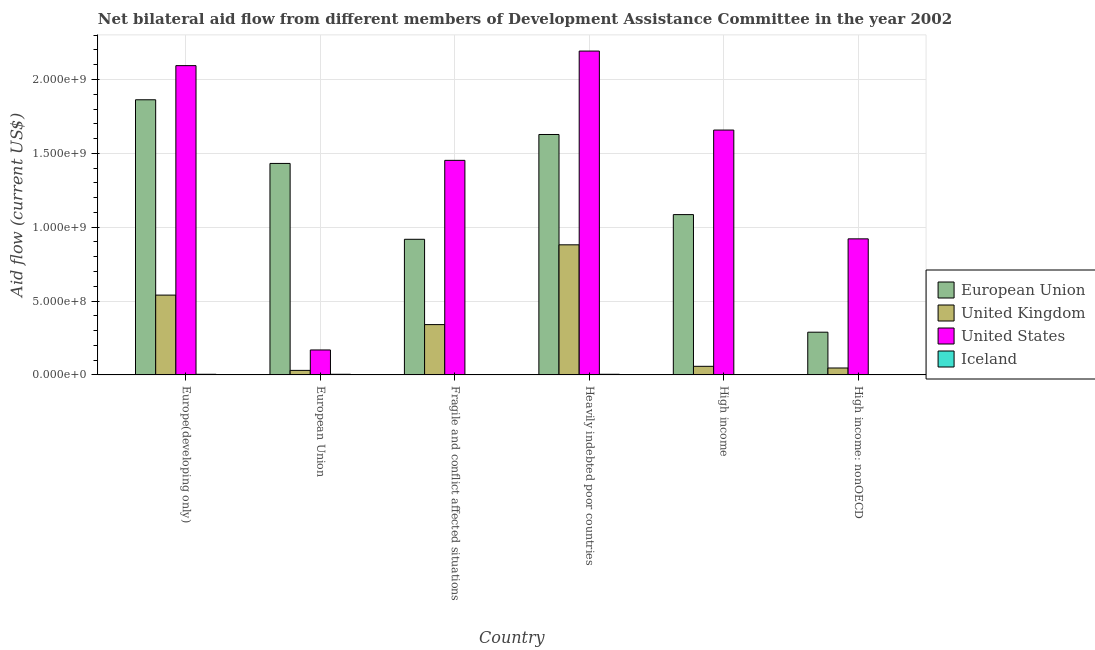How many groups of bars are there?
Provide a short and direct response. 6. Are the number of bars per tick equal to the number of legend labels?
Keep it short and to the point. Yes. What is the label of the 3rd group of bars from the left?
Your answer should be compact. Fragile and conflict affected situations. In how many cases, is the number of bars for a given country not equal to the number of legend labels?
Ensure brevity in your answer.  0. What is the amount of aid given by uk in High income?
Give a very brief answer. 5.81e+07. Across all countries, what is the maximum amount of aid given by eu?
Make the answer very short. 1.86e+09. Across all countries, what is the minimum amount of aid given by uk?
Provide a short and direct response. 3.07e+07. In which country was the amount of aid given by uk maximum?
Ensure brevity in your answer.  Heavily indebted poor countries. In which country was the amount of aid given by uk minimum?
Provide a short and direct response. European Union. What is the total amount of aid given by uk in the graph?
Provide a short and direct response. 1.90e+09. What is the difference between the amount of aid given by us in Heavily indebted poor countries and that in High income?
Your response must be concise. 5.35e+08. What is the difference between the amount of aid given by us in High income: nonOECD and the amount of aid given by uk in High income?
Your answer should be compact. 8.63e+08. What is the average amount of aid given by uk per country?
Provide a succinct answer. 3.16e+08. What is the difference between the amount of aid given by us and amount of aid given by eu in High income?
Give a very brief answer. 5.72e+08. In how many countries, is the amount of aid given by iceland greater than 1300000000 US$?
Your response must be concise. 0. What is the ratio of the amount of aid given by eu in Fragile and conflict affected situations to that in High income?
Give a very brief answer. 0.85. Is the amount of aid given by uk in Fragile and conflict affected situations less than that in High income?
Give a very brief answer. No. What is the difference between the highest and the second highest amount of aid given by eu?
Your answer should be compact. 2.35e+08. What is the difference between the highest and the lowest amount of aid given by us?
Make the answer very short. 2.02e+09. Is the sum of the amount of aid given by us in European Union and High income: nonOECD greater than the maximum amount of aid given by uk across all countries?
Your response must be concise. Yes. Is it the case that in every country, the sum of the amount of aid given by iceland and amount of aid given by uk is greater than the sum of amount of aid given by eu and amount of aid given by us?
Offer a terse response. No. What does the 2nd bar from the right in High income represents?
Keep it short and to the point. United States. Are all the bars in the graph horizontal?
Provide a short and direct response. No. How many countries are there in the graph?
Offer a very short reply. 6. What is the difference between two consecutive major ticks on the Y-axis?
Make the answer very short. 5.00e+08. Does the graph contain any zero values?
Keep it short and to the point. No. Does the graph contain grids?
Provide a short and direct response. Yes. Where does the legend appear in the graph?
Offer a terse response. Center right. How are the legend labels stacked?
Offer a very short reply. Vertical. What is the title of the graph?
Offer a very short reply. Net bilateral aid flow from different members of Development Assistance Committee in the year 2002. Does "UNDP" appear as one of the legend labels in the graph?
Give a very brief answer. No. What is the label or title of the Y-axis?
Keep it short and to the point. Aid flow (current US$). What is the Aid flow (current US$) of European Union in Europe(developing only)?
Your response must be concise. 1.86e+09. What is the Aid flow (current US$) in United Kingdom in Europe(developing only)?
Your answer should be very brief. 5.40e+08. What is the Aid flow (current US$) of United States in Europe(developing only)?
Your answer should be compact. 2.09e+09. What is the Aid flow (current US$) of Iceland in Europe(developing only)?
Provide a short and direct response. 4.30e+06. What is the Aid flow (current US$) of European Union in European Union?
Your answer should be very brief. 1.43e+09. What is the Aid flow (current US$) of United Kingdom in European Union?
Provide a succinct answer. 3.07e+07. What is the Aid flow (current US$) of United States in European Union?
Your answer should be very brief. 1.69e+08. What is the Aid flow (current US$) of Iceland in European Union?
Offer a very short reply. 4.30e+06. What is the Aid flow (current US$) of European Union in Fragile and conflict affected situations?
Give a very brief answer. 9.18e+08. What is the Aid flow (current US$) in United Kingdom in Fragile and conflict affected situations?
Your response must be concise. 3.41e+08. What is the Aid flow (current US$) of United States in Fragile and conflict affected situations?
Your response must be concise. 1.45e+09. What is the Aid flow (current US$) of Iceland in Fragile and conflict affected situations?
Your response must be concise. 1.18e+06. What is the Aid flow (current US$) of European Union in Heavily indebted poor countries?
Keep it short and to the point. 1.63e+09. What is the Aid flow (current US$) of United Kingdom in Heavily indebted poor countries?
Offer a very short reply. 8.81e+08. What is the Aid flow (current US$) in United States in Heavily indebted poor countries?
Ensure brevity in your answer.  2.19e+09. What is the Aid flow (current US$) of Iceland in Heavily indebted poor countries?
Ensure brevity in your answer.  4.30e+06. What is the Aid flow (current US$) in European Union in High income?
Provide a succinct answer. 1.09e+09. What is the Aid flow (current US$) in United Kingdom in High income?
Keep it short and to the point. 5.81e+07. What is the Aid flow (current US$) in United States in High income?
Offer a terse response. 1.66e+09. What is the Aid flow (current US$) in Iceland in High income?
Make the answer very short. 1.57e+06. What is the Aid flow (current US$) in European Union in High income: nonOECD?
Make the answer very short. 2.89e+08. What is the Aid flow (current US$) in United Kingdom in High income: nonOECD?
Offer a terse response. 4.68e+07. What is the Aid flow (current US$) in United States in High income: nonOECD?
Your response must be concise. 9.21e+08. What is the Aid flow (current US$) in Iceland in High income: nonOECD?
Provide a succinct answer. 1.07e+06. Across all countries, what is the maximum Aid flow (current US$) in European Union?
Provide a short and direct response. 1.86e+09. Across all countries, what is the maximum Aid flow (current US$) in United Kingdom?
Offer a terse response. 8.81e+08. Across all countries, what is the maximum Aid flow (current US$) in United States?
Give a very brief answer. 2.19e+09. Across all countries, what is the maximum Aid flow (current US$) in Iceland?
Offer a terse response. 4.30e+06. Across all countries, what is the minimum Aid flow (current US$) of European Union?
Ensure brevity in your answer.  2.89e+08. Across all countries, what is the minimum Aid flow (current US$) of United Kingdom?
Your response must be concise. 3.07e+07. Across all countries, what is the minimum Aid flow (current US$) in United States?
Your response must be concise. 1.69e+08. Across all countries, what is the minimum Aid flow (current US$) of Iceland?
Keep it short and to the point. 1.07e+06. What is the total Aid flow (current US$) of European Union in the graph?
Your answer should be very brief. 7.22e+09. What is the total Aid flow (current US$) of United Kingdom in the graph?
Make the answer very short. 1.90e+09. What is the total Aid flow (current US$) in United States in the graph?
Provide a short and direct response. 8.49e+09. What is the total Aid flow (current US$) of Iceland in the graph?
Your answer should be very brief. 1.67e+07. What is the difference between the Aid flow (current US$) of European Union in Europe(developing only) and that in European Union?
Your answer should be very brief. 4.31e+08. What is the difference between the Aid flow (current US$) of United Kingdom in Europe(developing only) and that in European Union?
Your answer should be very brief. 5.10e+08. What is the difference between the Aid flow (current US$) in United States in Europe(developing only) and that in European Union?
Offer a terse response. 1.93e+09. What is the difference between the Aid flow (current US$) in Iceland in Europe(developing only) and that in European Union?
Your answer should be compact. 0. What is the difference between the Aid flow (current US$) of European Union in Europe(developing only) and that in Fragile and conflict affected situations?
Make the answer very short. 9.45e+08. What is the difference between the Aid flow (current US$) of United Kingdom in Europe(developing only) and that in Fragile and conflict affected situations?
Provide a succinct answer. 2.00e+08. What is the difference between the Aid flow (current US$) of United States in Europe(developing only) and that in Fragile and conflict affected situations?
Offer a terse response. 6.41e+08. What is the difference between the Aid flow (current US$) in Iceland in Europe(developing only) and that in Fragile and conflict affected situations?
Give a very brief answer. 3.12e+06. What is the difference between the Aid flow (current US$) of European Union in Europe(developing only) and that in Heavily indebted poor countries?
Keep it short and to the point. 2.35e+08. What is the difference between the Aid flow (current US$) in United Kingdom in Europe(developing only) and that in Heavily indebted poor countries?
Ensure brevity in your answer.  -3.41e+08. What is the difference between the Aid flow (current US$) in United States in Europe(developing only) and that in Heavily indebted poor countries?
Offer a terse response. -9.86e+07. What is the difference between the Aid flow (current US$) in Iceland in Europe(developing only) and that in Heavily indebted poor countries?
Ensure brevity in your answer.  0. What is the difference between the Aid flow (current US$) in European Union in Europe(developing only) and that in High income?
Give a very brief answer. 7.77e+08. What is the difference between the Aid flow (current US$) of United Kingdom in Europe(developing only) and that in High income?
Offer a very short reply. 4.82e+08. What is the difference between the Aid flow (current US$) in United States in Europe(developing only) and that in High income?
Keep it short and to the point. 4.36e+08. What is the difference between the Aid flow (current US$) in Iceland in Europe(developing only) and that in High income?
Your response must be concise. 2.73e+06. What is the difference between the Aid flow (current US$) in European Union in Europe(developing only) and that in High income: nonOECD?
Your response must be concise. 1.57e+09. What is the difference between the Aid flow (current US$) in United Kingdom in Europe(developing only) and that in High income: nonOECD?
Provide a succinct answer. 4.93e+08. What is the difference between the Aid flow (current US$) in United States in Europe(developing only) and that in High income: nonOECD?
Your answer should be compact. 1.17e+09. What is the difference between the Aid flow (current US$) of Iceland in Europe(developing only) and that in High income: nonOECD?
Ensure brevity in your answer.  3.23e+06. What is the difference between the Aid flow (current US$) of European Union in European Union and that in Fragile and conflict affected situations?
Your answer should be very brief. 5.14e+08. What is the difference between the Aid flow (current US$) of United Kingdom in European Union and that in Fragile and conflict affected situations?
Your answer should be very brief. -3.10e+08. What is the difference between the Aid flow (current US$) in United States in European Union and that in Fragile and conflict affected situations?
Your answer should be compact. -1.28e+09. What is the difference between the Aid flow (current US$) in Iceland in European Union and that in Fragile and conflict affected situations?
Keep it short and to the point. 3.12e+06. What is the difference between the Aid flow (current US$) in European Union in European Union and that in Heavily indebted poor countries?
Your answer should be very brief. -1.96e+08. What is the difference between the Aid flow (current US$) of United Kingdom in European Union and that in Heavily indebted poor countries?
Make the answer very short. -8.50e+08. What is the difference between the Aid flow (current US$) in United States in European Union and that in Heavily indebted poor countries?
Give a very brief answer. -2.02e+09. What is the difference between the Aid flow (current US$) in Iceland in European Union and that in Heavily indebted poor countries?
Provide a short and direct response. 0. What is the difference between the Aid flow (current US$) of European Union in European Union and that in High income?
Your answer should be very brief. 3.46e+08. What is the difference between the Aid flow (current US$) in United Kingdom in European Union and that in High income?
Your answer should be compact. -2.74e+07. What is the difference between the Aid flow (current US$) in United States in European Union and that in High income?
Provide a short and direct response. -1.49e+09. What is the difference between the Aid flow (current US$) in Iceland in European Union and that in High income?
Make the answer very short. 2.73e+06. What is the difference between the Aid flow (current US$) in European Union in European Union and that in High income: nonOECD?
Provide a short and direct response. 1.14e+09. What is the difference between the Aid flow (current US$) of United Kingdom in European Union and that in High income: nonOECD?
Make the answer very short. -1.61e+07. What is the difference between the Aid flow (current US$) in United States in European Union and that in High income: nonOECD?
Keep it short and to the point. -7.52e+08. What is the difference between the Aid flow (current US$) in Iceland in European Union and that in High income: nonOECD?
Your response must be concise. 3.23e+06. What is the difference between the Aid flow (current US$) in European Union in Fragile and conflict affected situations and that in Heavily indebted poor countries?
Your answer should be compact. -7.09e+08. What is the difference between the Aid flow (current US$) of United Kingdom in Fragile and conflict affected situations and that in Heavily indebted poor countries?
Keep it short and to the point. -5.40e+08. What is the difference between the Aid flow (current US$) of United States in Fragile and conflict affected situations and that in Heavily indebted poor countries?
Provide a short and direct response. -7.40e+08. What is the difference between the Aid flow (current US$) in Iceland in Fragile and conflict affected situations and that in Heavily indebted poor countries?
Provide a succinct answer. -3.12e+06. What is the difference between the Aid flow (current US$) in European Union in Fragile and conflict affected situations and that in High income?
Provide a succinct answer. -1.67e+08. What is the difference between the Aid flow (current US$) of United Kingdom in Fragile and conflict affected situations and that in High income?
Provide a short and direct response. 2.82e+08. What is the difference between the Aid flow (current US$) of United States in Fragile and conflict affected situations and that in High income?
Your response must be concise. -2.05e+08. What is the difference between the Aid flow (current US$) in Iceland in Fragile and conflict affected situations and that in High income?
Make the answer very short. -3.90e+05. What is the difference between the Aid flow (current US$) of European Union in Fragile and conflict affected situations and that in High income: nonOECD?
Make the answer very short. 6.29e+08. What is the difference between the Aid flow (current US$) of United Kingdom in Fragile and conflict affected situations and that in High income: nonOECD?
Your answer should be very brief. 2.94e+08. What is the difference between the Aid flow (current US$) in United States in Fragile and conflict affected situations and that in High income: nonOECD?
Offer a very short reply. 5.31e+08. What is the difference between the Aid flow (current US$) in European Union in Heavily indebted poor countries and that in High income?
Offer a terse response. 5.42e+08. What is the difference between the Aid flow (current US$) of United Kingdom in Heavily indebted poor countries and that in High income?
Make the answer very short. 8.23e+08. What is the difference between the Aid flow (current US$) of United States in Heavily indebted poor countries and that in High income?
Provide a short and direct response. 5.35e+08. What is the difference between the Aid flow (current US$) of Iceland in Heavily indebted poor countries and that in High income?
Provide a succinct answer. 2.73e+06. What is the difference between the Aid flow (current US$) in European Union in Heavily indebted poor countries and that in High income: nonOECD?
Your answer should be very brief. 1.34e+09. What is the difference between the Aid flow (current US$) in United Kingdom in Heavily indebted poor countries and that in High income: nonOECD?
Give a very brief answer. 8.34e+08. What is the difference between the Aid flow (current US$) of United States in Heavily indebted poor countries and that in High income: nonOECD?
Your response must be concise. 1.27e+09. What is the difference between the Aid flow (current US$) in Iceland in Heavily indebted poor countries and that in High income: nonOECD?
Offer a very short reply. 3.23e+06. What is the difference between the Aid flow (current US$) in European Union in High income and that in High income: nonOECD?
Keep it short and to the point. 7.96e+08. What is the difference between the Aid flow (current US$) in United Kingdom in High income and that in High income: nonOECD?
Your response must be concise. 1.13e+07. What is the difference between the Aid flow (current US$) of United States in High income and that in High income: nonOECD?
Give a very brief answer. 7.37e+08. What is the difference between the Aid flow (current US$) in Iceland in High income and that in High income: nonOECD?
Give a very brief answer. 5.00e+05. What is the difference between the Aid flow (current US$) of European Union in Europe(developing only) and the Aid flow (current US$) of United Kingdom in European Union?
Make the answer very short. 1.83e+09. What is the difference between the Aid flow (current US$) of European Union in Europe(developing only) and the Aid flow (current US$) of United States in European Union?
Ensure brevity in your answer.  1.69e+09. What is the difference between the Aid flow (current US$) in European Union in Europe(developing only) and the Aid flow (current US$) in Iceland in European Union?
Provide a succinct answer. 1.86e+09. What is the difference between the Aid flow (current US$) of United Kingdom in Europe(developing only) and the Aid flow (current US$) of United States in European Union?
Your response must be concise. 3.71e+08. What is the difference between the Aid flow (current US$) in United Kingdom in Europe(developing only) and the Aid flow (current US$) in Iceland in European Union?
Provide a short and direct response. 5.36e+08. What is the difference between the Aid flow (current US$) in United States in Europe(developing only) and the Aid flow (current US$) in Iceland in European Union?
Your answer should be compact. 2.09e+09. What is the difference between the Aid flow (current US$) of European Union in Europe(developing only) and the Aid flow (current US$) of United Kingdom in Fragile and conflict affected situations?
Provide a succinct answer. 1.52e+09. What is the difference between the Aid flow (current US$) in European Union in Europe(developing only) and the Aid flow (current US$) in United States in Fragile and conflict affected situations?
Keep it short and to the point. 4.10e+08. What is the difference between the Aid flow (current US$) of European Union in Europe(developing only) and the Aid flow (current US$) of Iceland in Fragile and conflict affected situations?
Provide a succinct answer. 1.86e+09. What is the difference between the Aid flow (current US$) in United Kingdom in Europe(developing only) and the Aid flow (current US$) in United States in Fragile and conflict affected situations?
Make the answer very short. -9.12e+08. What is the difference between the Aid flow (current US$) in United Kingdom in Europe(developing only) and the Aid flow (current US$) in Iceland in Fragile and conflict affected situations?
Provide a short and direct response. 5.39e+08. What is the difference between the Aid flow (current US$) of United States in Europe(developing only) and the Aid flow (current US$) of Iceland in Fragile and conflict affected situations?
Your response must be concise. 2.09e+09. What is the difference between the Aid flow (current US$) in European Union in Europe(developing only) and the Aid flow (current US$) in United Kingdom in Heavily indebted poor countries?
Keep it short and to the point. 9.82e+08. What is the difference between the Aid flow (current US$) of European Union in Europe(developing only) and the Aid flow (current US$) of United States in Heavily indebted poor countries?
Your answer should be compact. -3.30e+08. What is the difference between the Aid flow (current US$) of European Union in Europe(developing only) and the Aid flow (current US$) of Iceland in Heavily indebted poor countries?
Keep it short and to the point. 1.86e+09. What is the difference between the Aid flow (current US$) of United Kingdom in Europe(developing only) and the Aid flow (current US$) of United States in Heavily indebted poor countries?
Ensure brevity in your answer.  -1.65e+09. What is the difference between the Aid flow (current US$) of United Kingdom in Europe(developing only) and the Aid flow (current US$) of Iceland in Heavily indebted poor countries?
Make the answer very short. 5.36e+08. What is the difference between the Aid flow (current US$) in United States in Europe(developing only) and the Aid flow (current US$) in Iceland in Heavily indebted poor countries?
Make the answer very short. 2.09e+09. What is the difference between the Aid flow (current US$) in European Union in Europe(developing only) and the Aid flow (current US$) in United Kingdom in High income?
Make the answer very short. 1.80e+09. What is the difference between the Aid flow (current US$) of European Union in Europe(developing only) and the Aid flow (current US$) of United States in High income?
Make the answer very short. 2.05e+08. What is the difference between the Aid flow (current US$) of European Union in Europe(developing only) and the Aid flow (current US$) of Iceland in High income?
Your response must be concise. 1.86e+09. What is the difference between the Aid flow (current US$) of United Kingdom in Europe(developing only) and the Aid flow (current US$) of United States in High income?
Your response must be concise. -1.12e+09. What is the difference between the Aid flow (current US$) in United Kingdom in Europe(developing only) and the Aid flow (current US$) in Iceland in High income?
Provide a short and direct response. 5.39e+08. What is the difference between the Aid flow (current US$) in United States in Europe(developing only) and the Aid flow (current US$) in Iceland in High income?
Your answer should be compact. 2.09e+09. What is the difference between the Aid flow (current US$) of European Union in Europe(developing only) and the Aid flow (current US$) of United Kingdom in High income: nonOECD?
Your response must be concise. 1.82e+09. What is the difference between the Aid flow (current US$) of European Union in Europe(developing only) and the Aid flow (current US$) of United States in High income: nonOECD?
Your answer should be compact. 9.42e+08. What is the difference between the Aid flow (current US$) in European Union in Europe(developing only) and the Aid flow (current US$) in Iceland in High income: nonOECD?
Offer a terse response. 1.86e+09. What is the difference between the Aid flow (current US$) of United Kingdom in Europe(developing only) and the Aid flow (current US$) of United States in High income: nonOECD?
Ensure brevity in your answer.  -3.81e+08. What is the difference between the Aid flow (current US$) of United Kingdom in Europe(developing only) and the Aid flow (current US$) of Iceland in High income: nonOECD?
Keep it short and to the point. 5.39e+08. What is the difference between the Aid flow (current US$) of United States in Europe(developing only) and the Aid flow (current US$) of Iceland in High income: nonOECD?
Provide a succinct answer. 2.09e+09. What is the difference between the Aid flow (current US$) of European Union in European Union and the Aid flow (current US$) of United Kingdom in Fragile and conflict affected situations?
Provide a succinct answer. 1.09e+09. What is the difference between the Aid flow (current US$) of European Union in European Union and the Aid flow (current US$) of United States in Fragile and conflict affected situations?
Keep it short and to the point. -2.08e+07. What is the difference between the Aid flow (current US$) in European Union in European Union and the Aid flow (current US$) in Iceland in Fragile and conflict affected situations?
Give a very brief answer. 1.43e+09. What is the difference between the Aid flow (current US$) of United Kingdom in European Union and the Aid flow (current US$) of United States in Fragile and conflict affected situations?
Your answer should be compact. -1.42e+09. What is the difference between the Aid flow (current US$) in United Kingdom in European Union and the Aid flow (current US$) in Iceland in Fragile and conflict affected situations?
Keep it short and to the point. 2.95e+07. What is the difference between the Aid flow (current US$) of United States in European Union and the Aid flow (current US$) of Iceland in Fragile and conflict affected situations?
Provide a succinct answer. 1.68e+08. What is the difference between the Aid flow (current US$) in European Union in European Union and the Aid flow (current US$) in United Kingdom in Heavily indebted poor countries?
Offer a terse response. 5.51e+08. What is the difference between the Aid flow (current US$) of European Union in European Union and the Aid flow (current US$) of United States in Heavily indebted poor countries?
Provide a succinct answer. -7.61e+08. What is the difference between the Aid flow (current US$) in European Union in European Union and the Aid flow (current US$) in Iceland in Heavily indebted poor countries?
Your answer should be very brief. 1.43e+09. What is the difference between the Aid flow (current US$) in United Kingdom in European Union and the Aid flow (current US$) in United States in Heavily indebted poor countries?
Make the answer very short. -2.16e+09. What is the difference between the Aid flow (current US$) of United Kingdom in European Union and the Aid flow (current US$) of Iceland in Heavily indebted poor countries?
Your answer should be compact. 2.64e+07. What is the difference between the Aid flow (current US$) of United States in European Union and the Aid flow (current US$) of Iceland in Heavily indebted poor countries?
Your answer should be compact. 1.65e+08. What is the difference between the Aid flow (current US$) of European Union in European Union and the Aid flow (current US$) of United Kingdom in High income?
Give a very brief answer. 1.37e+09. What is the difference between the Aid flow (current US$) in European Union in European Union and the Aid flow (current US$) in United States in High income?
Your answer should be very brief. -2.26e+08. What is the difference between the Aid flow (current US$) in European Union in European Union and the Aid flow (current US$) in Iceland in High income?
Provide a succinct answer. 1.43e+09. What is the difference between the Aid flow (current US$) of United Kingdom in European Union and the Aid flow (current US$) of United States in High income?
Make the answer very short. -1.63e+09. What is the difference between the Aid flow (current US$) in United Kingdom in European Union and the Aid flow (current US$) in Iceland in High income?
Your response must be concise. 2.91e+07. What is the difference between the Aid flow (current US$) in United States in European Union and the Aid flow (current US$) in Iceland in High income?
Make the answer very short. 1.67e+08. What is the difference between the Aid flow (current US$) of European Union in European Union and the Aid flow (current US$) of United Kingdom in High income: nonOECD?
Give a very brief answer. 1.39e+09. What is the difference between the Aid flow (current US$) of European Union in European Union and the Aid flow (current US$) of United States in High income: nonOECD?
Ensure brevity in your answer.  5.11e+08. What is the difference between the Aid flow (current US$) in European Union in European Union and the Aid flow (current US$) in Iceland in High income: nonOECD?
Your response must be concise. 1.43e+09. What is the difference between the Aid flow (current US$) of United Kingdom in European Union and the Aid flow (current US$) of United States in High income: nonOECD?
Your answer should be compact. -8.91e+08. What is the difference between the Aid flow (current US$) in United Kingdom in European Union and the Aid flow (current US$) in Iceland in High income: nonOECD?
Keep it short and to the point. 2.96e+07. What is the difference between the Aid flow (current US$) of United States in European Union and the Aid flow (current US$) of Iceland in High income: nonOECD?
Ensure brevity in your answer.  1.68e+08. What is the difference between the Aid flow (current US$) in European Union in Fragile and conflict affected situations and the Aid flow (current US$) in United Kingdom in Heavily indebted poor countries?
Offer a terse response. 3.74e+07. What is the difference between the Aid flow (current US$) of European Union in Fragile and conflict affected situations and the Aid flow (current US$) of United States in Heavily indebted poor countries?
Provide a succinct answer. -1.27e+09. What is the difference between the Aid flow (current US$) of European Union in Fragile and conflict affected situations and the Aid flow (current US$) of Iceland in Heavily indebted poor countries?
Ensure brevity in your answer.  9.14e+08. What is the difference between the Aid flow (current US$) of United Kingdom in Fragile and conflict affected situations and the Aid flow (current US$) of United States in Heavily indebted poor countries?
Give a very brief answer. -1.85e+09. What is the difference between the Aid flow (current US$) in United Kingdom in Fragile and conflict affected situations and the Aid flow (current US$) in Iceland in Heavily indebted poor countries?
Your response must be concise. 3.36e+08. What is the difference between the Aid flow (current US$) in United States in Fragile and conflict affected situations and the Aid flow (current US$) in Iceland in Heavily indebted poor countries?
Give a very brief answer. 1.45e+09. What is the difference between the Aid flow (current US$) of European Union in Fragile and conflict affected situations and the Aid flow (current US$) of United Kingdom in High income?
Provide a short and direct response. 8.60e+08. What is the difference between the Aid flow (current US$) of European Union in Fragile and conflict affected situations and the Aid flow (current US$) of United States in High income?
Keep it short and to the point. -7.40e+08. What is the difference between the Aid flow (current US$) of European Union in Fragile and conflict affected situations and the Aid flow (current US$) of Iceland in High income?
Offer a terse response. 9.17e+08. What is the difference between the Aid flow (current US$) in United Kingdom in Fragile and conflict affected situations and the Aid flow (current US$) in United States in High income?
Your response must be concise. -1.32e+09. What is the difference between the Aid flow (current US$) in United Kingdom in Fragile and conflict affected situations and the Aid flow (current US$) in Iceland in High income?
Your answer should be very brief. 3.39e+08. What is the difference between the Aid flow (current US$) of United States in Fragile and conflict affected situations and the Aid flow (current US$) of Iceland in High income?
Give a very brief answer. 1.45e+09. What is the difference between the Aid flow (current US$) of European Union in Fragile and conflict affected situations and the Aid flow (current US$) of United Kingdom in High income: nonOECD?
Offer a very short reply. 8.71e+08. What is the difference between the Aid flow (current US$) in European Union in Fragile and conflict affected situations and the Aid flow (current US$) in United States in High income: nonOECD?
Make the answer very short. -2.94e+06. What is the difference between the Aid flow (current US$) in European Union in Fragile and conflict affected situations and the Aid flow (current US$) in Iceland in High income: nonOECD?
Give a very brief answer. 9.17e+08. What is the difference between the Aid flow (current US$) in United Kingdom in Fragile and conflict affected situations and the Aid flow (current US$) in United States in High income: nonOECD?
Your response must be concise. -5.81e+08. What is the difference between the Aid flow (current US$) in United Kingdom in Fragile and conflict affected situations and the Aid flow (current US$) in Iceland in High income: nonOECD?
Offer a terse response. 3.40e+08. What is the difference between the Aid flow (current US$) of United States in Fragile and conflict affected situations and the Aid flow (current US$) of Iceland in High income: nonOECD?
Your answer should be very brief. 1.45e+09. What is the difference between the Aid flow (current US$) of European Union in Heavily indebted poor countries and the Aid flow (current US$) of United Kingdom in High income?
Make the answer very short. 1.57e+09. What is the difference between the Aid flow (current US$) of European Union in Heavily indebted poor countries and the Aid flow (current US$) of United States in High income?
Provide a short and direct response. -3.01e+07. What is the difference between the Aid flow (current US$) in European Union in Heavily indebted poor countries and the Aid flow (current US$) in Iceland in High income?
Offer a very short reply. 1.63e+09. What is the difference between the Aid flow (current US$) of United Kingdom in Heavily indebted poor countries and the Aid flow (current US$) of United States in High income?
Ensure brevity in your answer.  -7.77e+08. What is the difference between the Aid flow (current US$) in United Kingdom in Heavily indebted poor countries and the Aid flow (current US$) in Iceland in High income?
Make the answer very short. 8.79e+08. What is the difference between the Aid flow (current US$) of United States in Heavily indebted poor countries and the Aid flow (current US$) of Iceland in High income?
Your answer should be compact. 2.19e+09. What is the difference between the Aid flow (current US$) in European Union in Heavily indebted poor countries and the Aid flow (current US$) in United Kingdom in High income: nonOECD?
Provide a succinct answer. 1.58e+09. What is the difference between the Aid flow (current US$) in European Union in Heavily indebted poor countries and the Aid flow (current US$) in United States in High income: nonOECD?
Your response must be concise. 7.07e+08. What is the difference between the Aid flow (current US$) of European Union in Heavily indebted poor countries and the Aid flow (current US$) of Iceland in High income: nonOECD?
Your answer should be very brief. 1.63e+09. What is the difference between the Aid flow (current US$) of United Kingdom in Heavily indebted poor countries and the Aid flow (current US$) of United States in High income: nonOECD?
Make the answer very short. -4.04e+07. What is the difference between the Aid flow (current US$) in United Kingdom in Heavily indebted poor countries and the Aid flow (current US$) in Iceland in High income: nonOECD?
Keep it short and to the point. 8.80e+08. What is the difference between the Aid flow (current US$) in United States in Heavily indebted poor countries and the Aid flow (current US$) in Iceland in High income: nonOECD?
Provide a short and direct response. 2.19e+09. What is the difference between the Aid flow (current US$) of European Union in High income and the Aid flow (current US$) of United Kingdom in High income: nonOECD?
Offer a very short reply. 1.04e+09. What is the difference between the Aid flow (current US$) in European Union in High income and the Aid flow (current US$) in United States in High income: nonOECD?
Make the answer very short. 1.64e+08. What is the difference between the Aid flow (current US$) of European Union in High income and the Aid flow (current US$) of Iceland in High income: nonOECD?
Make the answer very short. 1.08e+09. What is the difference between the Aid flow (current US$) of United Kingdom in High income and the Aid flow (current US$) of United States in High income: nonOECD?
Make the answer very short. -8.63e+08. What is the difference between the Aid flow (current US$) of United Kingdom in High income and the Aid flow (current US$) of Iceland in High income: nonOECD?
Your response must be concise. 5.71e+07. What is the difference between the Aid flow (current US$) of United States in High income and the Aid flow (current US$) of Iceland in High income: nonOECD?
Your response must be concise. 1.66e+09. What is the average Aid flow (current US$) in European Union per country?
Ensure brevity in your answer.  1.20e+09. What is the average Aid flow (current US$) of United Kingdom per country?
Make the answer very short. 3.16e+08. What is the average Aid flow (current US$) of United States per country?
Your answer should be very brief. 1.41e+09. What is the average Aid flow (current US$) in Iceland per country?
Your answer should be very brief. 2.79e+06. What is the difference between the Aid flow (current US$) of European Union and Aid flow (current US$) of United Kingdom in Europe(developing only)?
Provide a succinct answer. 1.32e+09. What is the difference between the Aid flow (current US$) in European Union and Aid flow (current US$) in United States in Europe(developing only)?
Give a very brief answer. -2.31e+08. What is the difference between the Aid flow (current US$) of European Union and Aid flow (current US$) of Iceland in Europe(developing only)?
Your response must be concise. 1.86e+09. What is the difference between the Aid flow (current US$) in United Kingdom and Aid flow (current US$) in United States in Europe(developing only)?
Your response must be concise. -1.55e+09. What is the difference between the Aid flow (current US$) of United Kingdom and Aid flow (current US$) of Iceland in Europe(developing only)?
Provide a succinct answer. 5.36e+08. What is the difference between the Aid flow (current US$) in United States and Aid flow (current US$) in Iceland in Europe(developing only)?
Provide a succinct answer. 2.09e+09. What is the difference between the Aid flow (current US$) of European Union and Aid flow (current US$) of United Kingdom in European Union?
Keep it short and to the point. 1.40e+09. What is the difference between the Aid flow (current US$) in European Union and Aid flow (current US$) in United States in European Union?
Ensure brevity in your answer.  1.26e+09. What is the difference between the Aid flow (current US$) in European Union and Aid flow (current US$) in Iceland in European Union?
Provide a short and direct response. 1.43e+09. What is the difference between the Aid flow (current US$) in United Kingdom and Aid flow (current US$) in United States in European Union?
Your answer should be very brief. -1.38e+08. What is the difference between the Aid flow (current US$) of United Kingdom and Aid flow (current US$) of Iceland in European Union?
Your answer should be compact. 2.64e+07. What is the difference between the Aid flow (current US$) in United States and Aid flow (current US$) in Iceland in European Union?
Keep it short and to the point. 1.65e+08. What is the difference between the Aid flow (current US$) of European Union and Aid flow (current US$) of United Kingdom in Fragile and conflict affected situations?
Ensure brevity in your answer.  5.78e+08. What is the difference between the Aid flow (current US$) in European Union and Aid flow (current US$) in United States in Fragile and conflict affected situations?
Offer a very short reply. -5.34e+08. What is the difference between the Aid flow (current US$) in European Union and Aid flow (current US$) in Iceland in Fragile and conflict affected situations?
Offer a very short reply. 9.17e+08. What is the difference between the Aid flow (current US$) in United Kingdom and Aid flow (current US$) in United States in Fragile and conflict affected situations?
Your answer should be very brief. -1.11e+09. What is the difference between the Aid flow (current US$) of United Kingdom and Aid flow (current US$) of Iceland in Fragile and conflict affected situations?
Offer a very short reply. 3.39e+08. What is the difference between the Aid flow (current US$) in United States and Aid flow (current US$) in Iceland in Fragile and conflict affected situations?
Your answer should be very brief. 1.45e+09. What is the difference between the Aid flow (current US$) in European Union and Aid flow (current US$) in United Kingdom in Heavily indebted poor countries?
Offer a terse response. 7.47e+08. What is the difference between the Aid flow (current US$) in European Union and Aid flow (current US$) in United States in Heavily indebted poor countries?
Offer a very short reply. -5.65e+08. What is the difference between the Aid flow (current US$) of European Union and Aid flow (current US$) of Iceland in Heavily indebted poor countries?
Make the answer very short. 1.62e+09. What is the difference between the Aid flow (current US$) in United Kingdom and Aid flow (current US$) in United States in Heavily indebted poor countries?
Provide a short and direct response. -1.31e+09. What is the difference between the Aid flow (current US$) of United Kingdom and Aid flow (current US$) of Iceland in Heavily indebted poor countries?
Keep it short and to the point. 8.77e+08. What is the difference between the Aid flow (current US$) of United States and Aid flow (current US$) of Iceland in Heavily indebted poor countries?
Your answer should be very brief. 2.19e+09. What is the difference between the Aid flow (current US$) in European Union and Aid flow (current US$) in United Kingdom in High income?
Offer a very short reply. 1.03e+09. What is the difference between the Aid flow (current US$) in European Union and Aid flow (current US$) in United States in High income?
Ensure brevity in your answer.  -5.72e+08. What is the difference between the Aid flow (current US$) of European Union and Aid flow (current US$) of Iceland in High income?
Offer a very short reply. 1.08e+09. What is the difference between the Aid flow (current US$) in United Kingdom and Aid flow (current US$) in United States in High income?
Keep it short and to the point. -1.60e+09. What is the difference between the Aid flow (current US$) in United Kingdom and Aid flow (current US$) in Iceland in High income?
Your response must be concise. 5.66e+07. What is the difference between the Aid flow (current US$) of United States and Aid flow (current US$) of Iceland in High income?
Your answer should be very brief. 1.66e+09. What is the difference between the Aid flow (current US$) of European Union and Aid flow (current US$) of United Kingdom in High income: nonOECD?
Offer a terse response. 2.42e+08. What is the difference between the Aid flow (current US$) in European Union and Aid flow (current US$) in United States in High income: nonOECD?
Provide a short and direct response. -6.32e+08. What is the difference between the Aid flow (current US$) of European Union and Aid flow (current US$) of Iceland in High income: nonOECD?
Your answer should be very brief. 2.88e+08. What is the difference between the Aid flow (current US$) in United Kingdom and Aid flow (current US$) in United States in High income: nonOECD?
Your response must be concise. -8.74e+08. What is the difference between the Aid flow (current US$) of United Kingdom and Aid flow (current US$) of Iceland in High income: nonOECD?
Provide a succinct answer. 4.58e+07. What is the difference between the Aid flow (current US$) of United States and Aid flow (current US$) of Iceland in High income: nonOECD?
Offer a terse response. 9.20e+08. What is the ratio of the Aid flow (current US$) of European Union in Europe(developing only) to that in European Union?
Your answer should be compact. 1.3. What is the ratio of the Aid flow (current US$) of United Kingdom in Europe(developing only) to that in European Union?
Provide a succinct answer. 17.6. What is the ratio of the Aid flow (current US$) in United States in Europe(developing only) to that in European Union?
Make the answer very short. 12.4. What is the ratio of the Aid flow (current US$) of Iceland in Europe(developing only) to that in European Union?
Give a very brief answer. 1. What is the ratio of the Aid flow (current US$) in European Union in Europe(developing only) to that in Fragile and conflict affected situations?
Offer a terse response. 2.03. What is the ratio of the Aid flow (current US$) of United Kingdom in Europe(developing only) to that in Fragile and conflict affected situations?
Make the answer very short. 1.59. What is the ratio of the Aid flow (current US$) of United States in Europe(developing only) to that in Fragile and conflict affected situations?
Your answer should be compact. 1.44. What is the ratio of the Aid flow (current US$) in Iceland in Europe(developing only) to that in Fragile and conflict affected situations?
Your answer should be compact. 3.64. What is the ratio of the Aid flow (current US$) in European Union in Europe(developing only) to that in Heavily indebted poor countries?
Offer a terse response. 1.14. What is the ratio of the Aid flow (current US$) in United Kingdom in Europe(developing only) to that in Heavily indebted poor countries?
Give a very brief answer. 0.61. What is the ratio of the Aid flow (current US$) in United States in Europe(developing only) to that in Heavily indebted poor countries?
Give a very brief answer. 0.95. What is the ratio of the Aid flow (current US$) in European Union in Europe(developing only) to that in High income?
Keep it short and to the point. 1.72. What is the ratio of the Aid flow (current US$) in United Kingdom in Europe(developing only) to that in High income?
Provide a short and direct response. 9.29. What is the ratio of the Aid flow (current US$) of United States in Europe(developing only) to that in High income?
Offer a very short reply. 1.26. What is the ratio of the Aid flow (current US$) of Iceland in Europe(developing only) to that in High income?
Provide a succinct answer. 2.74. What is the ratio of the Aid flow (current US$) of European Union in Europe(developing only) to that in High income: nonOECD?
Your answer should be compact. 6.44. What is the ratio of the Aid flow (current US$) in United Kingdom in Europe(developing only) to that in High income: nonOECD?
Give a very brief answer. 11.54. What is the ratio of the Aid flow (current US$) in United States in Europe(developing only) to that in High income: nonOECD?
Offer a very short reply. 2.27. What is the ratio of the Aid flow (current US$) of Iceland in Europe(developing only) to that in High income: nonOECD?
Offer a very short reply. 4.02. What is the ratio of the Aid flow (current US$) of European Union in European Union to that in Fragile and conflict affected situations?
Give a very brief answer. 1.56. What is the ratio of the Aid flow (current US$) in United Kingdom in European Union to that in Fragile and conflict affected situations?
Give a very brief answer. 0.09. What is the ratio of the Aid flow (current US$) in United States in European Union to that in Fragile and conflict affected situations?
Make the answer very short. 0.12. What is the ratio of the Aid flow (current US$) in Iceland in European Union to that in Fragile and conflict affected situations?
Your answer should be compact. 3.64. What is the ratio of the Aid flow (current US$) of European Union in European Union to that in Heavily indebted poor countries?
Your answer should be very brief. 0.88. What is the ratio of the Aid flow (current US$) in United Kingdom in European Union to that in Heavily indebted poor countries?
Your answer should be compact. 0.03. What is the ratio of the Aid flow (current US$) of United States in European Union to that in Heavily indebted poor countries?
Provide a succinct answer. 0.08. What is the ratio of the Aid flow (current US$) in European Union in European Union to that in High income?
Your answer should be very brief. 1.32. What is the ratio of the Aid flow (current US$) in United Kingdom in European Union to that in High income?
Ensure brevity in your answer.  0.53. What is the ratio of the Aid flow (current US$) of United States in European Union to that in High income?
Your response must be concise. 0.1. What is the ratio of the Aid flow (current US$) of Iceland in European Union to that in High income?
Your answer should be compact. 2.74. What is the ratio of the Aid flow (current US$) of European Union in European Union to that in High income: nonOECD?
Provide a succinct answer. 4.95. What is the ratio of the Aid flow (current US$) of United Kingdom in European Union to that in High income: nonOECD?
Your response must be concise. 0.66. What is the ratio of the Aid flow (current US$) of United States in European Union to that in High income: nonOECD?
Keep it short and to the point. 0.18. What is the ratio of the Aid flow (current US$) in Iceland in European Union to that in High income: nonOECD?
Ensure brevity in your answer.  4.02. What is the ratio of the Aid flow (current US$) in European Union in Fragile and conflict affected situations to that in Heavily indebted poor countries?
Offer a very short reply. 0.56. What is the ratio of the Aid flow (current US$) in United Kingdom in Fragile and conflict affected situations to that in Heavily indebted poor countries?
Give a very brief answer. 0.39. What is the ratio of the Aid flow (current US$) in United States in Fragile and conflict affected situations to that in Heavily indebted poor countries?
Your answer should be very brief. 0.66. What is the ratio of the Aid flow (current US$) of Iceland in Fragile and conflict affected situations to that in Heavily indebted poor countries?
Provide a short and direct response. 0.27. What is the ratio of the Aid flow (current US$) of European Union in Fragile and conflict affected situations to that in High income?
Provide a succinct answer. 0.85. What is the ratio of the Aid flow (current US$) of United Kingdom in Fragile and conflict affected situations to that in High income?
Give a very brief answer. 5.86. What is the ratio of the Aid flow (current US$) in United States in Fragile and conflict affected situations to that in High income?
Ensure brevity in your answer.  0.88. What is the ratio of the Aid flow (current US$) of Iceland in Fragile and conflict affected situations to that in High income?
Provide a short and direct response. 0.75. What is the ratio of the Aid flow (current US$) in European Union in Fragile and conflict affected situations to that in High income: nonOECD?
Offer a terse response. 3.18. What is the ratio of the Aid flow (current US$) of United Kingdom in Fragile and conflict affected situations to that in High income: nonOECD?
Offer a very short reply. 7.27. What is the ratio of the Aid flow (current US$) in United States in Fragile and conflict affected situations to that in High income: nonOECD?
Offer a terse response. 1.58. What is the ratio of the Aid flow (current US$) of Iceland in Fragile and conflict affected situations to that in High income: nonOECD?
Ensure brevity in your answer.  1.1. What is the ratio of the Aid flow (current US$) of European Union in Heavily indebted poor countries to that in High income?
Your answer should be very brief. 1.5. What is the ratio of the Aid flow (current US$) in United Kingdom in Heavily indebted poor countries to that in High income?
Your answer should be very brief. 15.15. What is the ratio of the Aid flow (current US$) of United States in Heavily indebted poor countries to that in High income?
Provide a succinct answer. 1.32. What is the ratio of the Aid flow (current US$) of Iceland in Heavily indebted poor countries to that in High income?
Keep it short and to the point. 2.74. What is the ratio of the Aid flow (current US$) in European Union in Heavily indebted poor countries to that in High income: nonOECD?
Give a very brief answer. 5.63. What is the ratio of the Aid flow (current US$) in United Kingdom in Heavily indebted poor countries to that in High income: nonOECD?
Offer a very short reply. 18.81. What is the ratio of the Aid flow (current US$) of United States in Heavily indebted poor countries to that in High income: nonOECD?
Give a very brief answer. 2.38. What is the ratio of the Aid flow (current US$) of Iceland in Heavily indebted poor countries to that in High income: nonOECD?
Your answer should be compact. 4.02. What is the ratio of the Aid flow (current US$) of European Union in High income to that in High income: nonOECD?
Ensure brevity in your answer.  3.75. What is the ratio of the Aid flow (current US$) of United Kingdom in High income to that in High income: nonOECD?
Make the answer very short. 1.24. What is the ratio of the Aid flow (current US$) of United States in High income to that in High income: nonOECD?
Ensure brevity in your answer.  1.8. What is the ratio of the Aid flow (current US$) in Iceland in High income to that in High income: nonOECD?
Give a very brief answer. 1.47. What is the difference between the highest and the second highest Aid flow (current US$) of European Union?
Ensure brevity in your answer.  2.35e+08. What is the difference between the highest and the second highest Aid flow (current US$) in United Kingdom?
Your response must be concise. 3.41e+08. What is the difference between the highest and the second highest Aid flow (current US$) of United States?
Your answer should be compact. 9.86e+07. What is the difference between the highest and the lowest Aid flow (current US$) of European Union?
Offer a terse response. 1.57e+09. What is the difference between the highest and the lowest Aid flow (current US$) in United Kingdom?
Your response must be concise. 8.50e+08. What is the difference between the highest and the lowest Aid flow (current US$) in United States?
Provide a succinct answer. 2.02e+09. What is the difference between the highest and the lowest Aid flow (current US$) of Iceland?
Your answer should be very brief. 3.23e+06. 